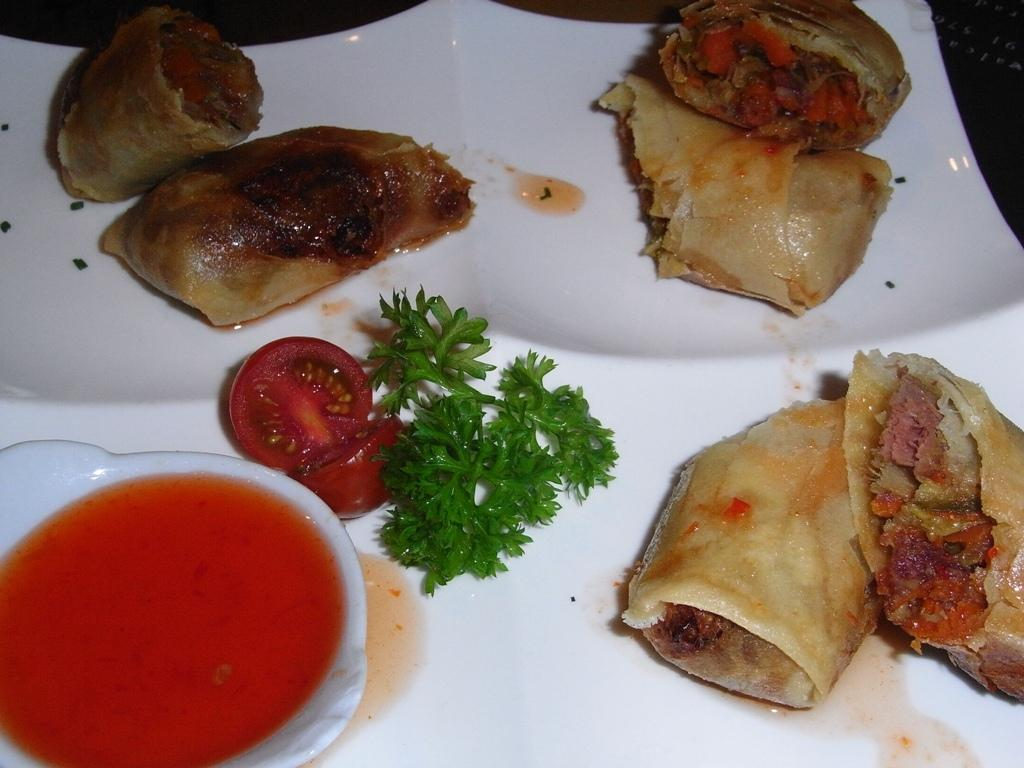What is on the plate that is visible in the image? There is food on a plate in the image. What type of food is in the bowl on the left side of the image? There is a bowl of soup on the left side of the image. How many rods can be seen in the image? There are no rods present in the image. What type of bubbles are floating in the soup? There are no bubbles visible in the image, and the soup is not described as having bubbles. 